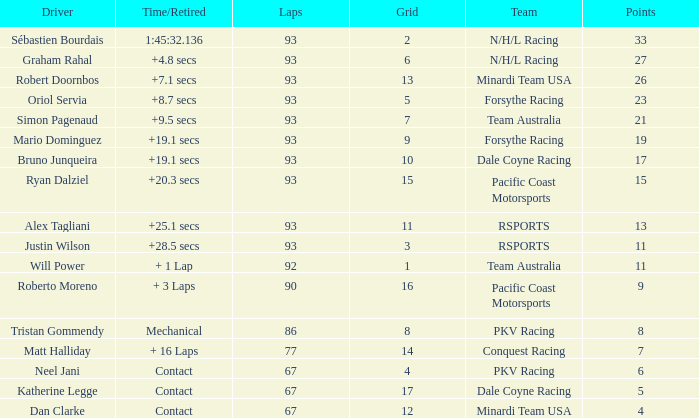What is the grid for the Minardi Team USA with laps smaller than 90? 12.0. 